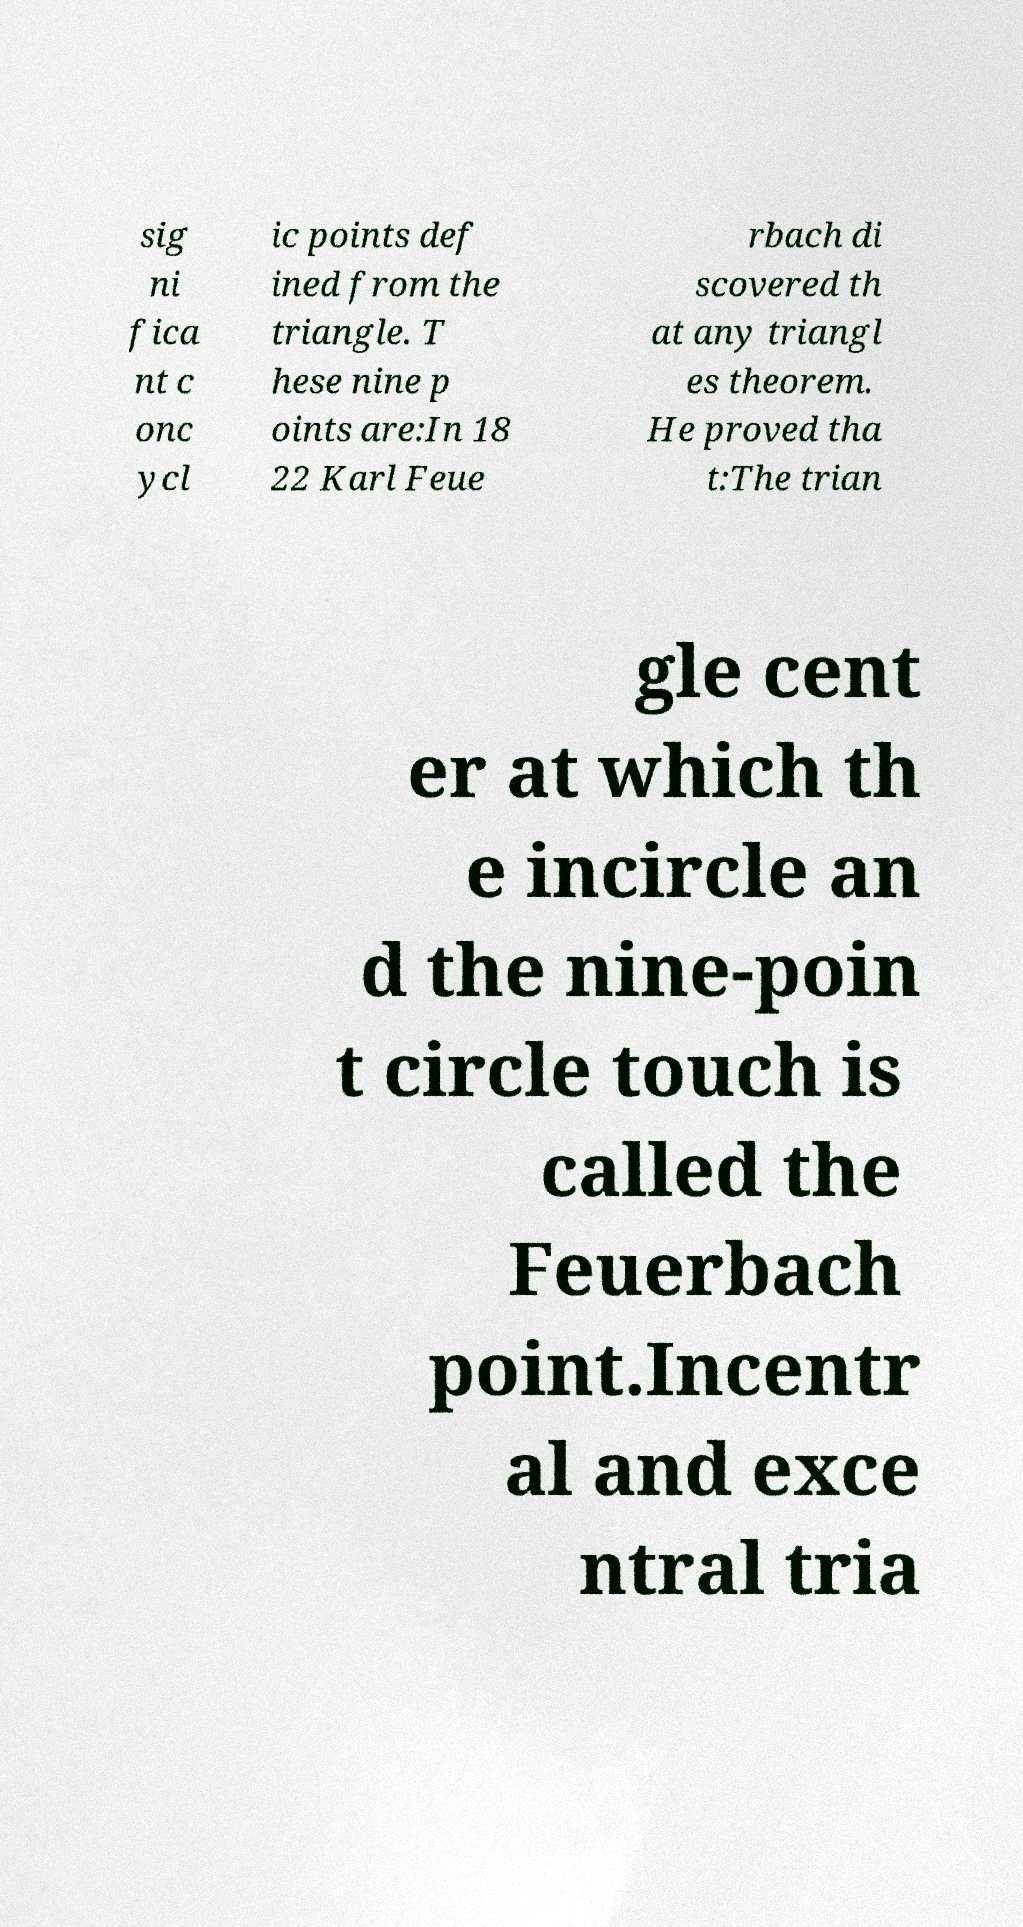Could you assist in decoding the text presented in this image and type it out clearly? sig ni fica nt c onc ycl ic points def ined from the triangle. T hese nine p oints are:In 18 22 Karl Feue rbach di scovered th at any triangl es theorem. He proved tha t:The trian gle cent er at which th e incircle an d the nine-poin t circle touch is called the Feuerbach point.Incentr al and exce ntral tria 